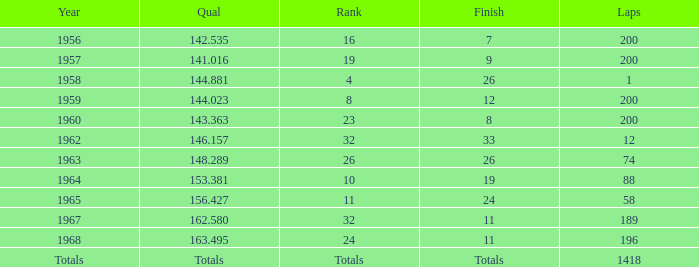Which qual also has a finish total of 9? 141.016. 